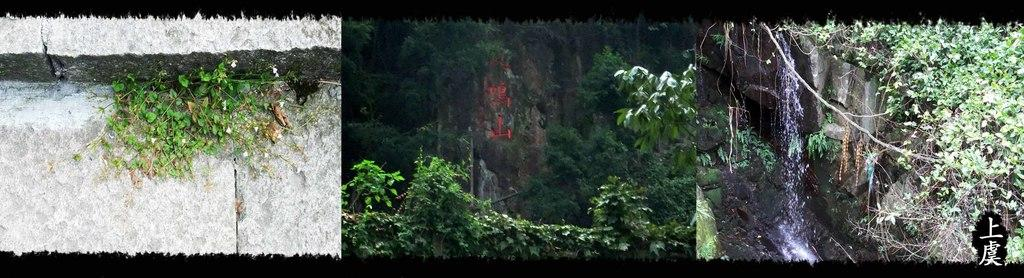What type of natural feature is depicted in the collage photos? The collage photos contain images of waterfalls. What other natural elements are present in the collage photos? The collage photos contain images of trees and plants. Are there any man-made structures visible in the collage photos? Yes, the collage photos contain images of walls. Who is the owner of the club featured in the collage photos? There is no mention of a club or an owner in the collage photos; they contain images of waterfalls, trees, walls, and plants. 